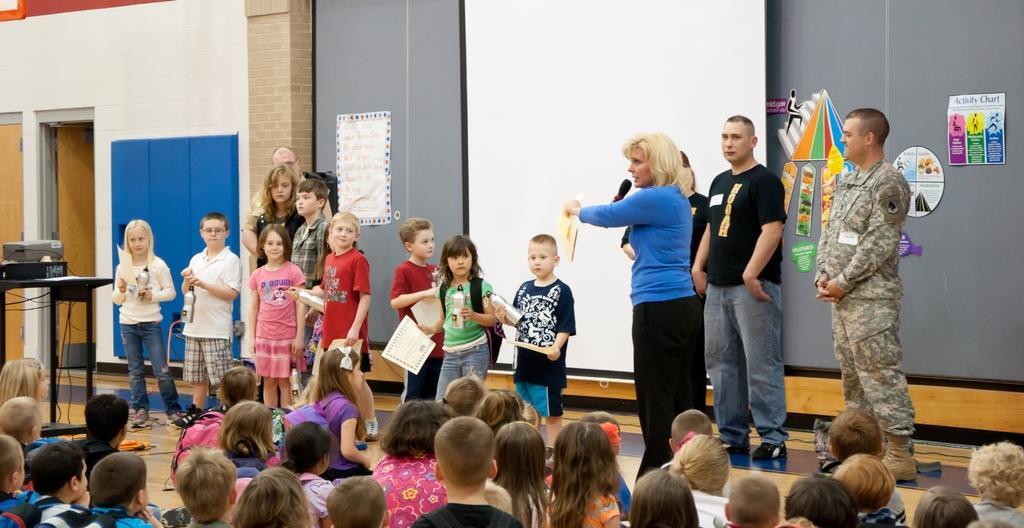How would you summarize this image in a sentence or two? In this image we can see some persons standing on the floor. There is a woman holding the book and also the mike and talking. We can also see the kids standing and holding the bottles and also the certificates. There are kids sitting on the floor. We can also see the table with some objects. Image also consists of doors, wall, board and some papers attached to the wall. 